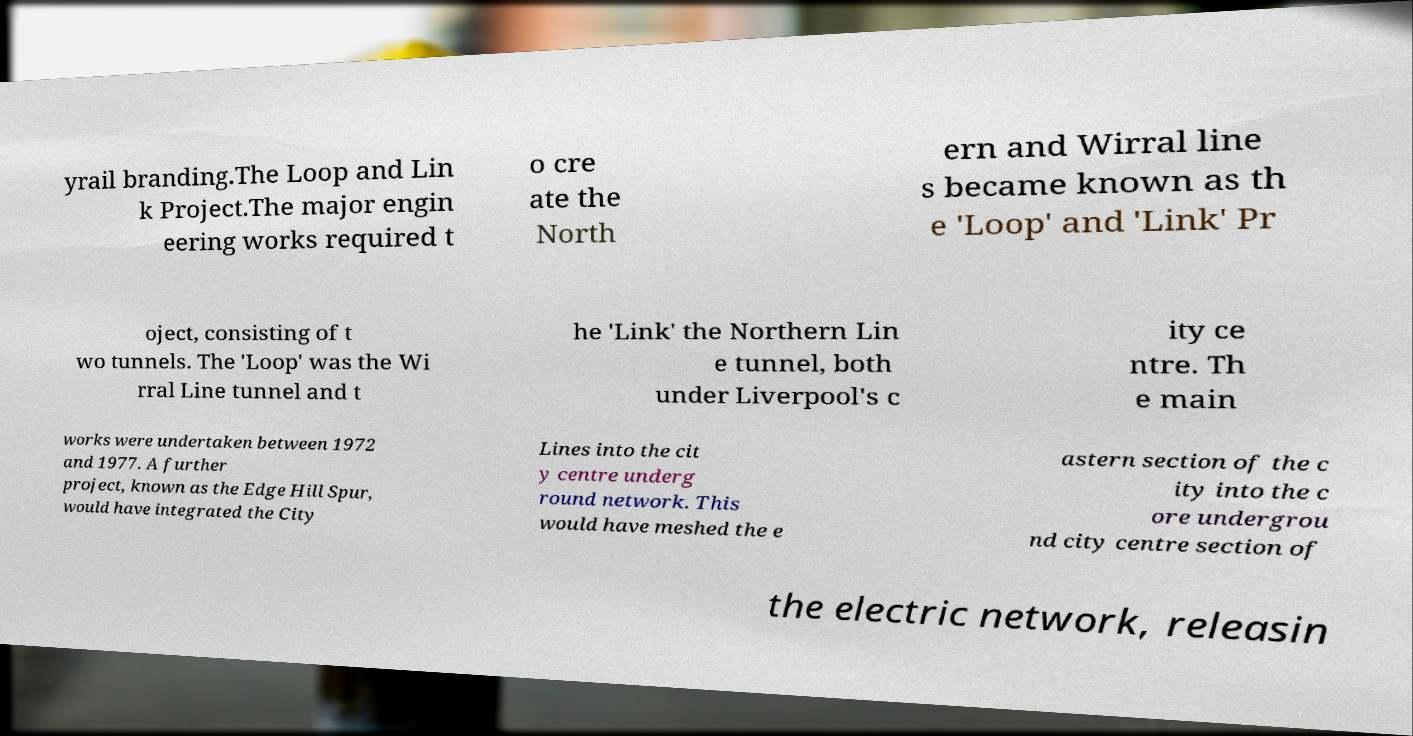Please identify and transcribe the text found in this image. yrail branding.The Loop and Lin k Project.The major engin eering works required t o cre ate the North ern and Wirral line s became known as th e 'Loop' and 'Link' Pr oject, consisting of t wo tunnels. The 'Loop' was the Wi rral Line tunnel and t he 'Link' the Northern Lin e tunnel, both under Liverpool's c ity ce ntre. Th e main works were undertaken between 1972 and 1977. A further project, known as the Edge Hill Spur, would have integrated the City Lines into the cit y centre underg round network. This would have meshed the e astern section of the c ity into the c ore undergrou nd city centre section of the electric network, releasin 